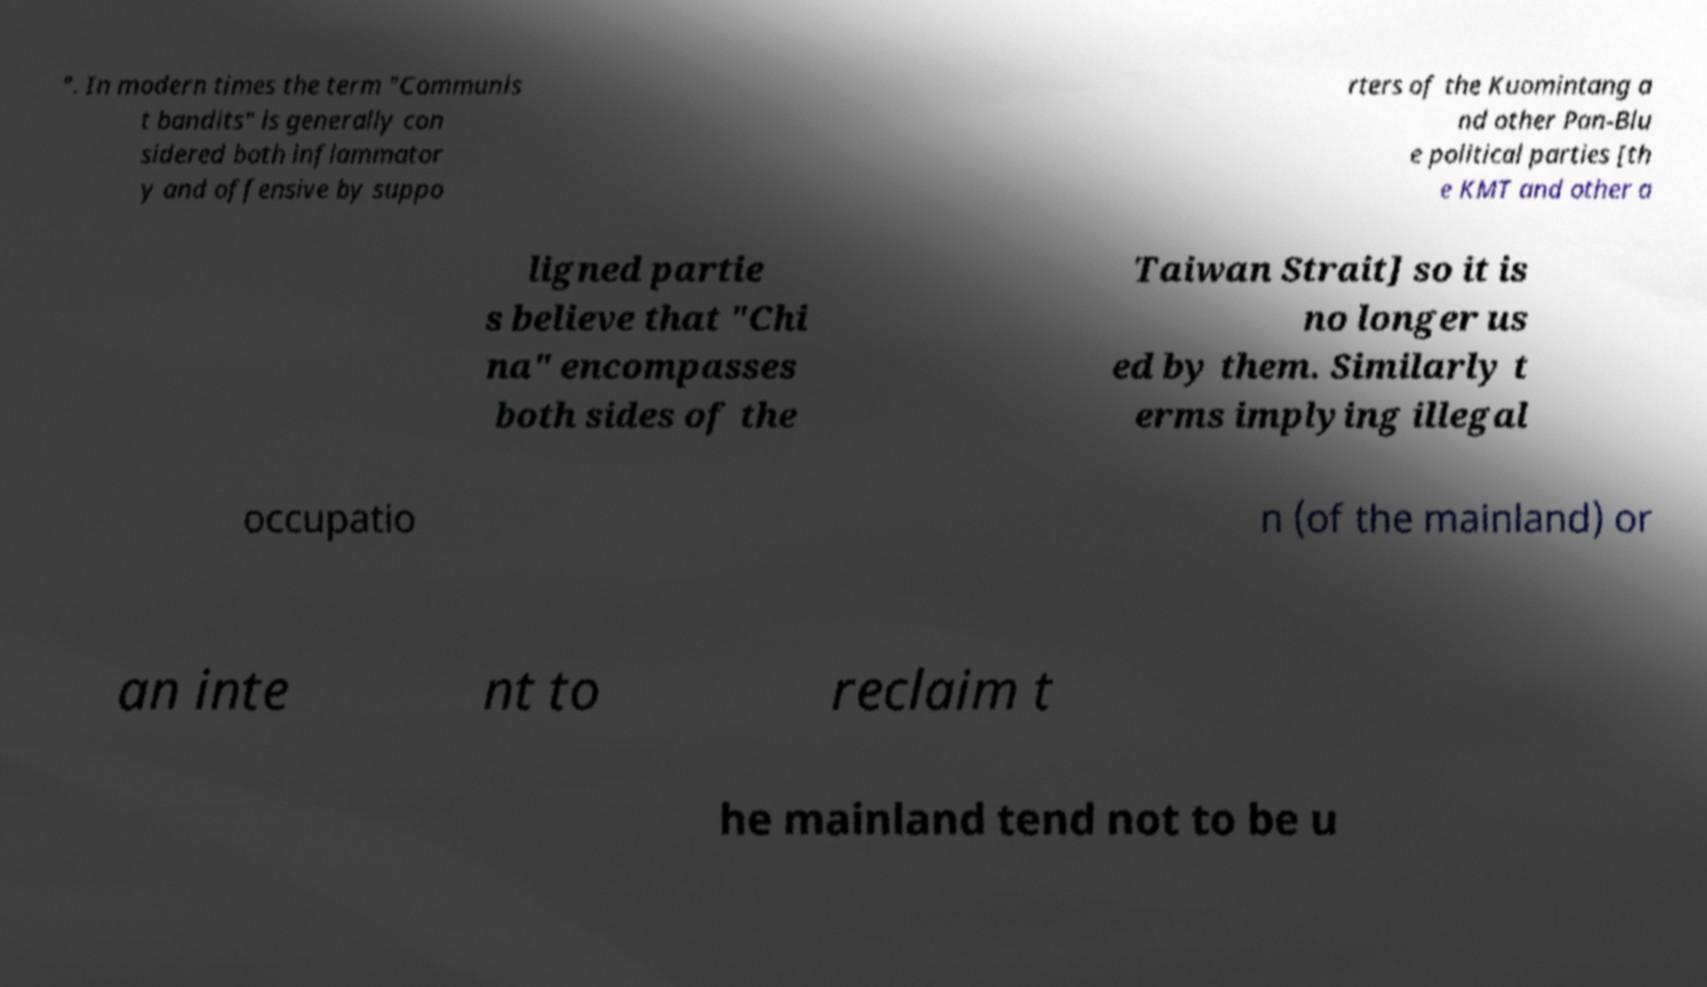Can you accurately transcribe the text from the provided image for me? ". In modern times the term "Communis t bandits" is generally con sidered both inflammator y and offensive by suppo rters of the Kuomintang a nd other Pan-Blu e political parties [th e KMT and other a ligned partie s believe that "Chi na" encompasses both sides of the Taiwan Strait] so it is no longer us ed by them. Similarly t erms implying illegal occupatio n (of the mainland) or an inte nt to reclaim t he mainland tend not to be u 